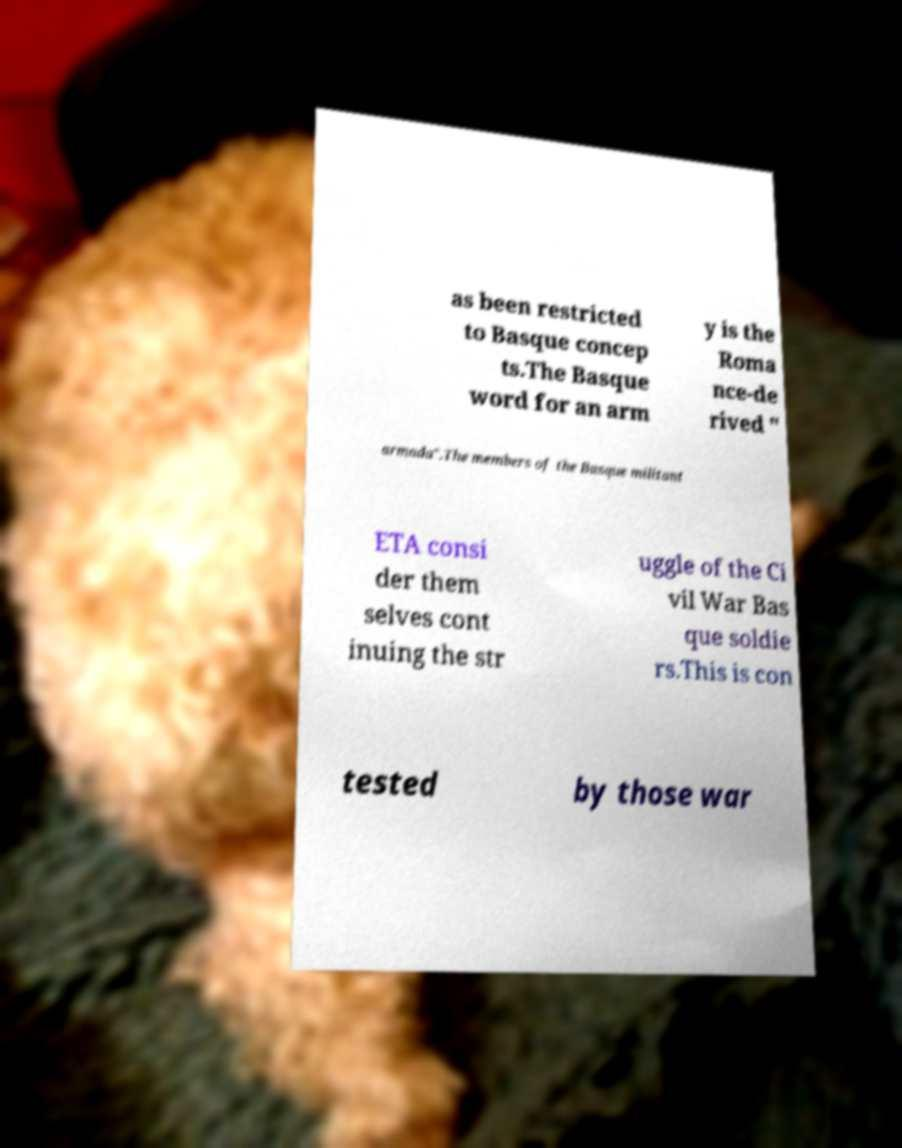Can you read and provide the text displayed in the image?This photo seems to have some interesting text. Can you extract and type it out for me? as been restricted to Basque concep ts.The Basque word for an arm y is the Roma nce-de rived " armada".The members of the Basque militant ETA consi der them selves cont inuing the str uggle of the Ci vil War Bas que soldie rs.This is con tested by those war 